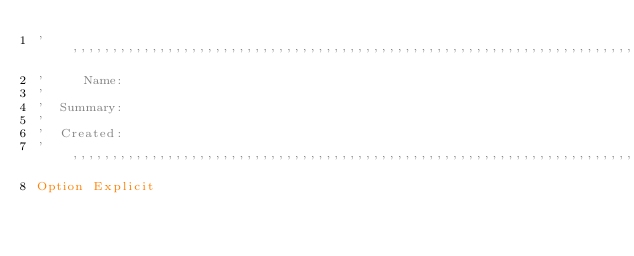Convert code to text. <code><loc_0><loc_0><loc_500><loc_500><_VisualBasic_>''''''''''''''''''''''''''''''''''''''''''''''''''''''''''''''''''''''''''''''
'     Name:
'
'  Summary:
'
'  Created:
''''''''''''''''''''''''''''''''''''''''''''''''''''''''''''''''''''''''''''''
Option Explicit
</code> 